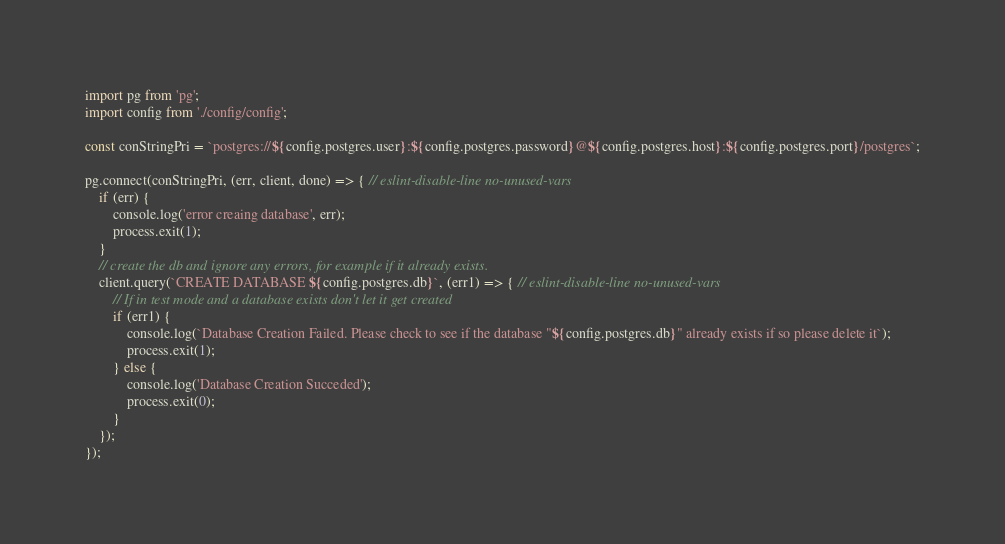<code> <loc_0><loc_0><loc_500><loc_500><_JavaScript_>import pg from 'pg';
import config from './config/config';

const conStringPri = `postgres://${config.postgres.user}:${config.postgres.password}@${config.postgres.host}:${config.postgres.port}/postgres`;

pg.connect(conStringPri, (err, client, done) => { // eslint-disable-line no-unused-vars
    if (err) {
        console.log('error creaing database', err);
        process.exit(1);
    }
    // create the db and ignore any errors, for example if it already exists.
    client.query(`CREATE DATABASE ${config.postgres.db}`, (err1) => { // eslint-disable-line no-unused-vars
        // If in test mode and a database exists don't let it get created
        if (err1) {
            console.log(`Database Creation Failed. Please check to see if the database "${config.postgres.db}" already exists if so please delete it`);
            process.exit(1);
        } else {
            console.log('Database Creation Succeded');
            process.exit(0);
        }
    });
});
</code> 